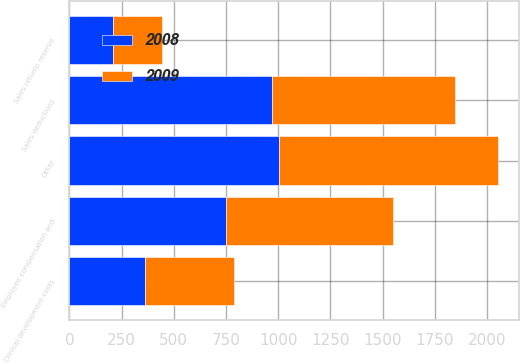<chart> <loc_0><loc_0><loc_500><loc_500><stacked_bar_chart><ecel><fcel>Sales deductions<fcel>Employee compensation and<fcel>Clinical development costs<fcel>Sales returns reserve<fcel>Other<nl><fcel>2008<fcel>970<fcel>751<fcel>361<fcel>211<fcel>1006<nl><fcel>2009<fcel>876<fcel>799<fcel>429<fcel>233<fcel>1045<nl></chart> 